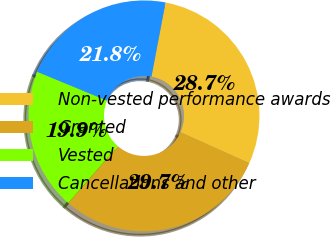Convert chart. <chart><loc_0><loc_0><loc_500><loc_500><pie_chart><fcel>Non-vested performance awards<fcel>Granted<fcel>Vested<fcel>Cancellations and other<nl><fcel>28.74%<fcel>29.66%<fcel>19.85%<fcel>21.75%<nl></chart> 